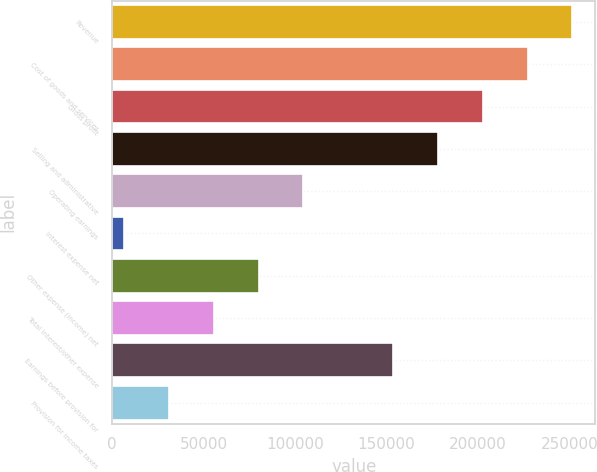Convert chart. <chart><loc_0><loc_0><loc_500><loc_500><bar_chart><fcel>Revenue<fcel>Cost of goods and services<fcel>Gross profit<fcel>Selling and administrative<fcel>Operating earnings<fcel>Interest expense net<fcel>Other expense (income) net<fcel>Total interest/other expense<fcel>Earnings before provision for<fcel>Provision for income taxes<nl><fcel>251618<fcel>227101<fcel>202584<fcel>178067<fcel>104516<fcel>6448<fcel>79999<fcel>55482<fcel>153550<fcel>30965<nl></chart> 